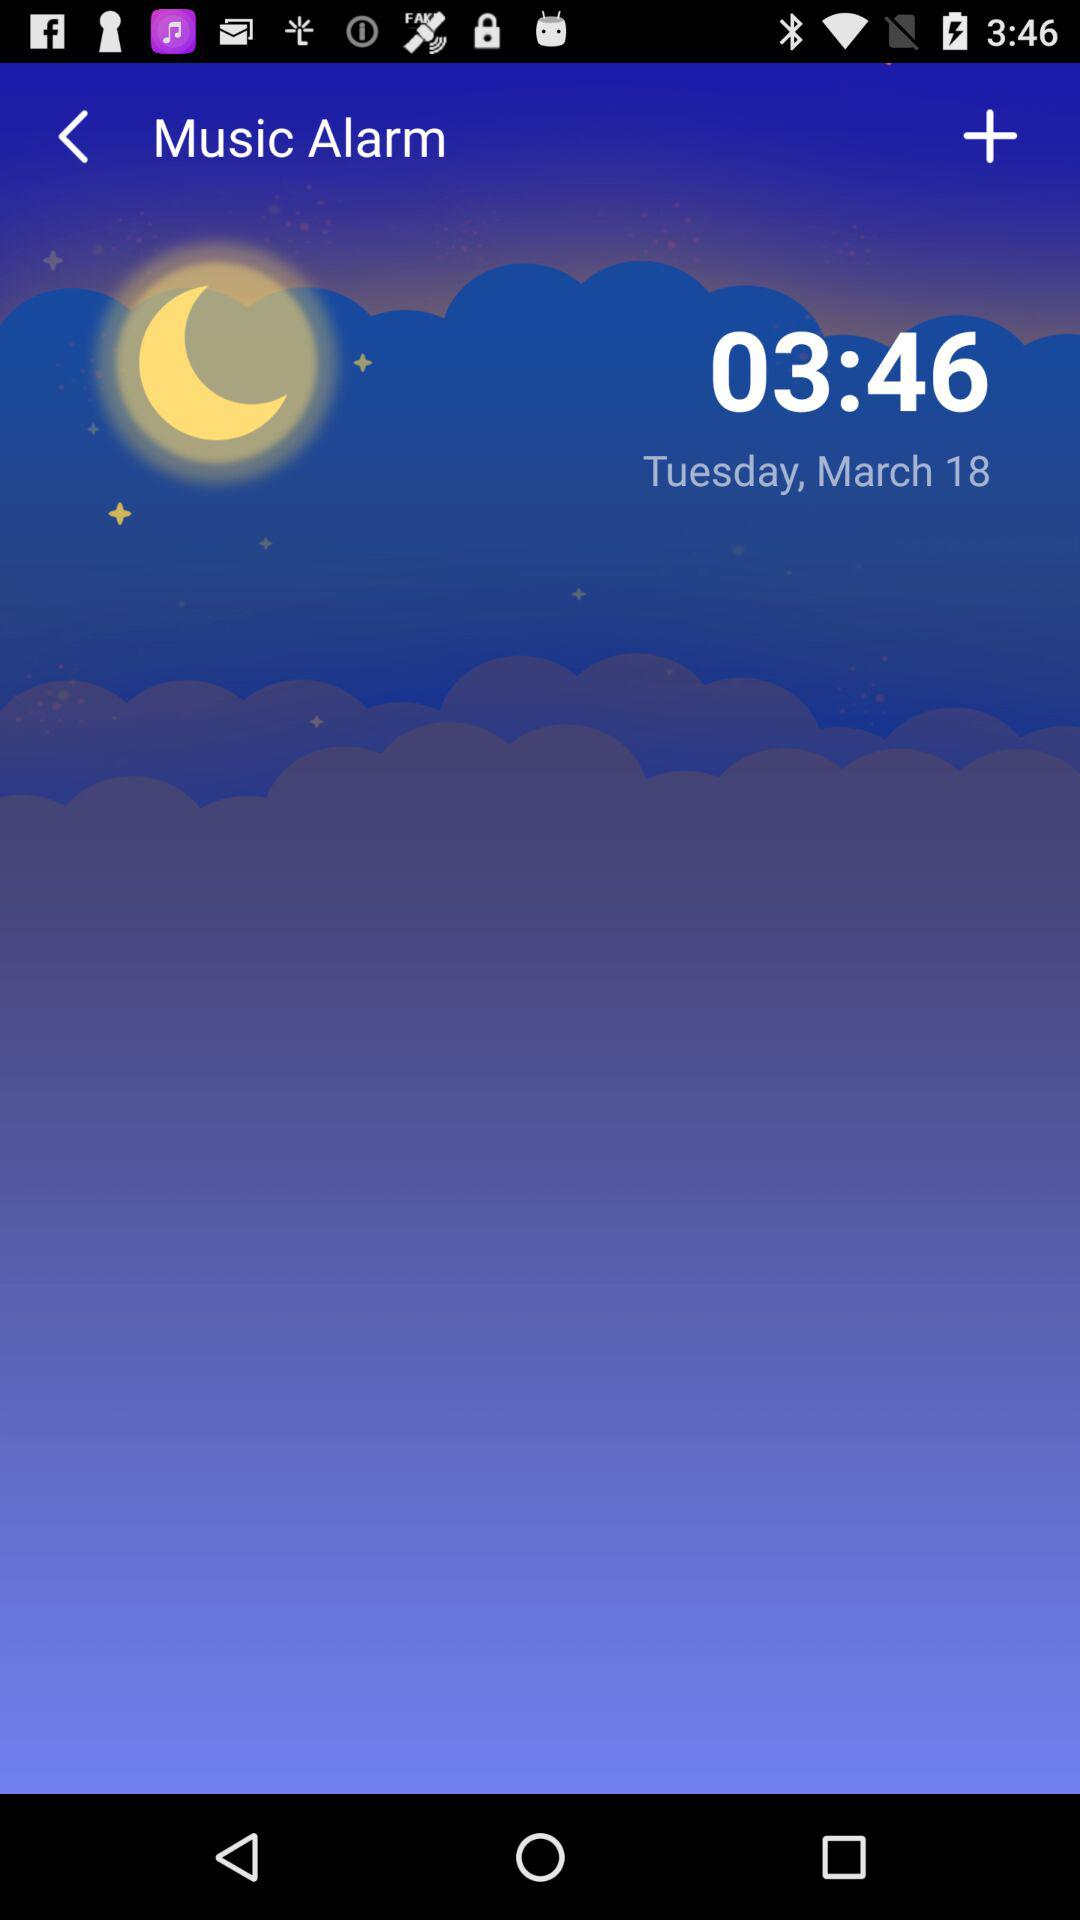What is the day on March 18? The day is Tuesday. 